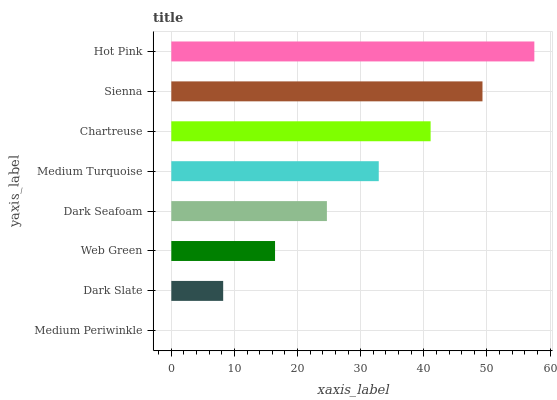Is Medium Periwinkle the minimum?
Answer yes or no. Yes. Is Hot Pink the maximum?
Answer yes or no. Yes. Is Dark Slate the minimum?
Answer yes or no. No. Is Dark Slate the maximum?
Answer yes or no. No. Is Dark Slate greater than Medium Periwinkle?
Answer yes or no. Yes. Is Medium Periwinkle less than Dark Slate?
Answer yes or no. Yes. Is Medium Periwinkle greater than Dark Slate?
Answer yes or no. No. Is Dark Slate less than Medium Periwinkle?
Answer yes or no. No. Is Medium Turquoise the high median?
Answer yes or no. Yes. Is Dark Seafoam the low median?
Answer yes or no. Yes. Is Sienna the high median?
Answer yes or no. No. Is Web Green the low median?
Answer yes or no. No. 